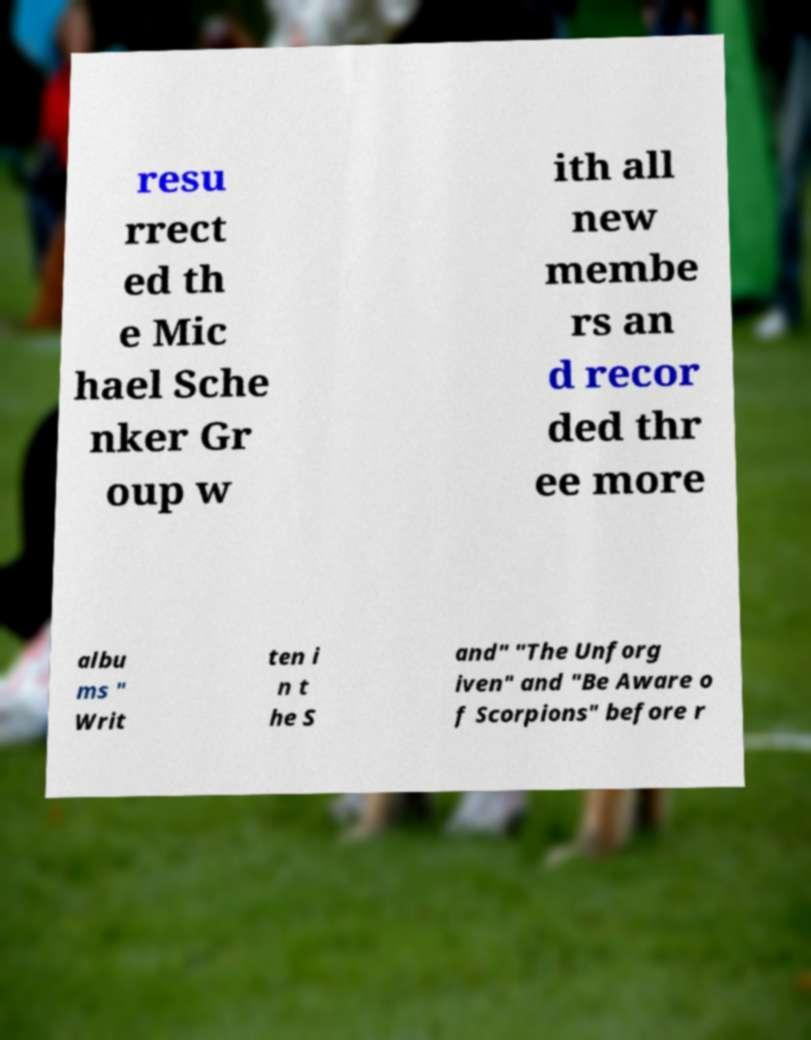I need the written content from this picture converted into text. Can you do that? resu rrect ed th e Mic hael Sche nker Gr oup w ith all new membe rs an d recor ded thr ee more albu ms " Writ ten i n t he S and" "The Unforg iven" and "Be Aware o f Scorpions" before r 